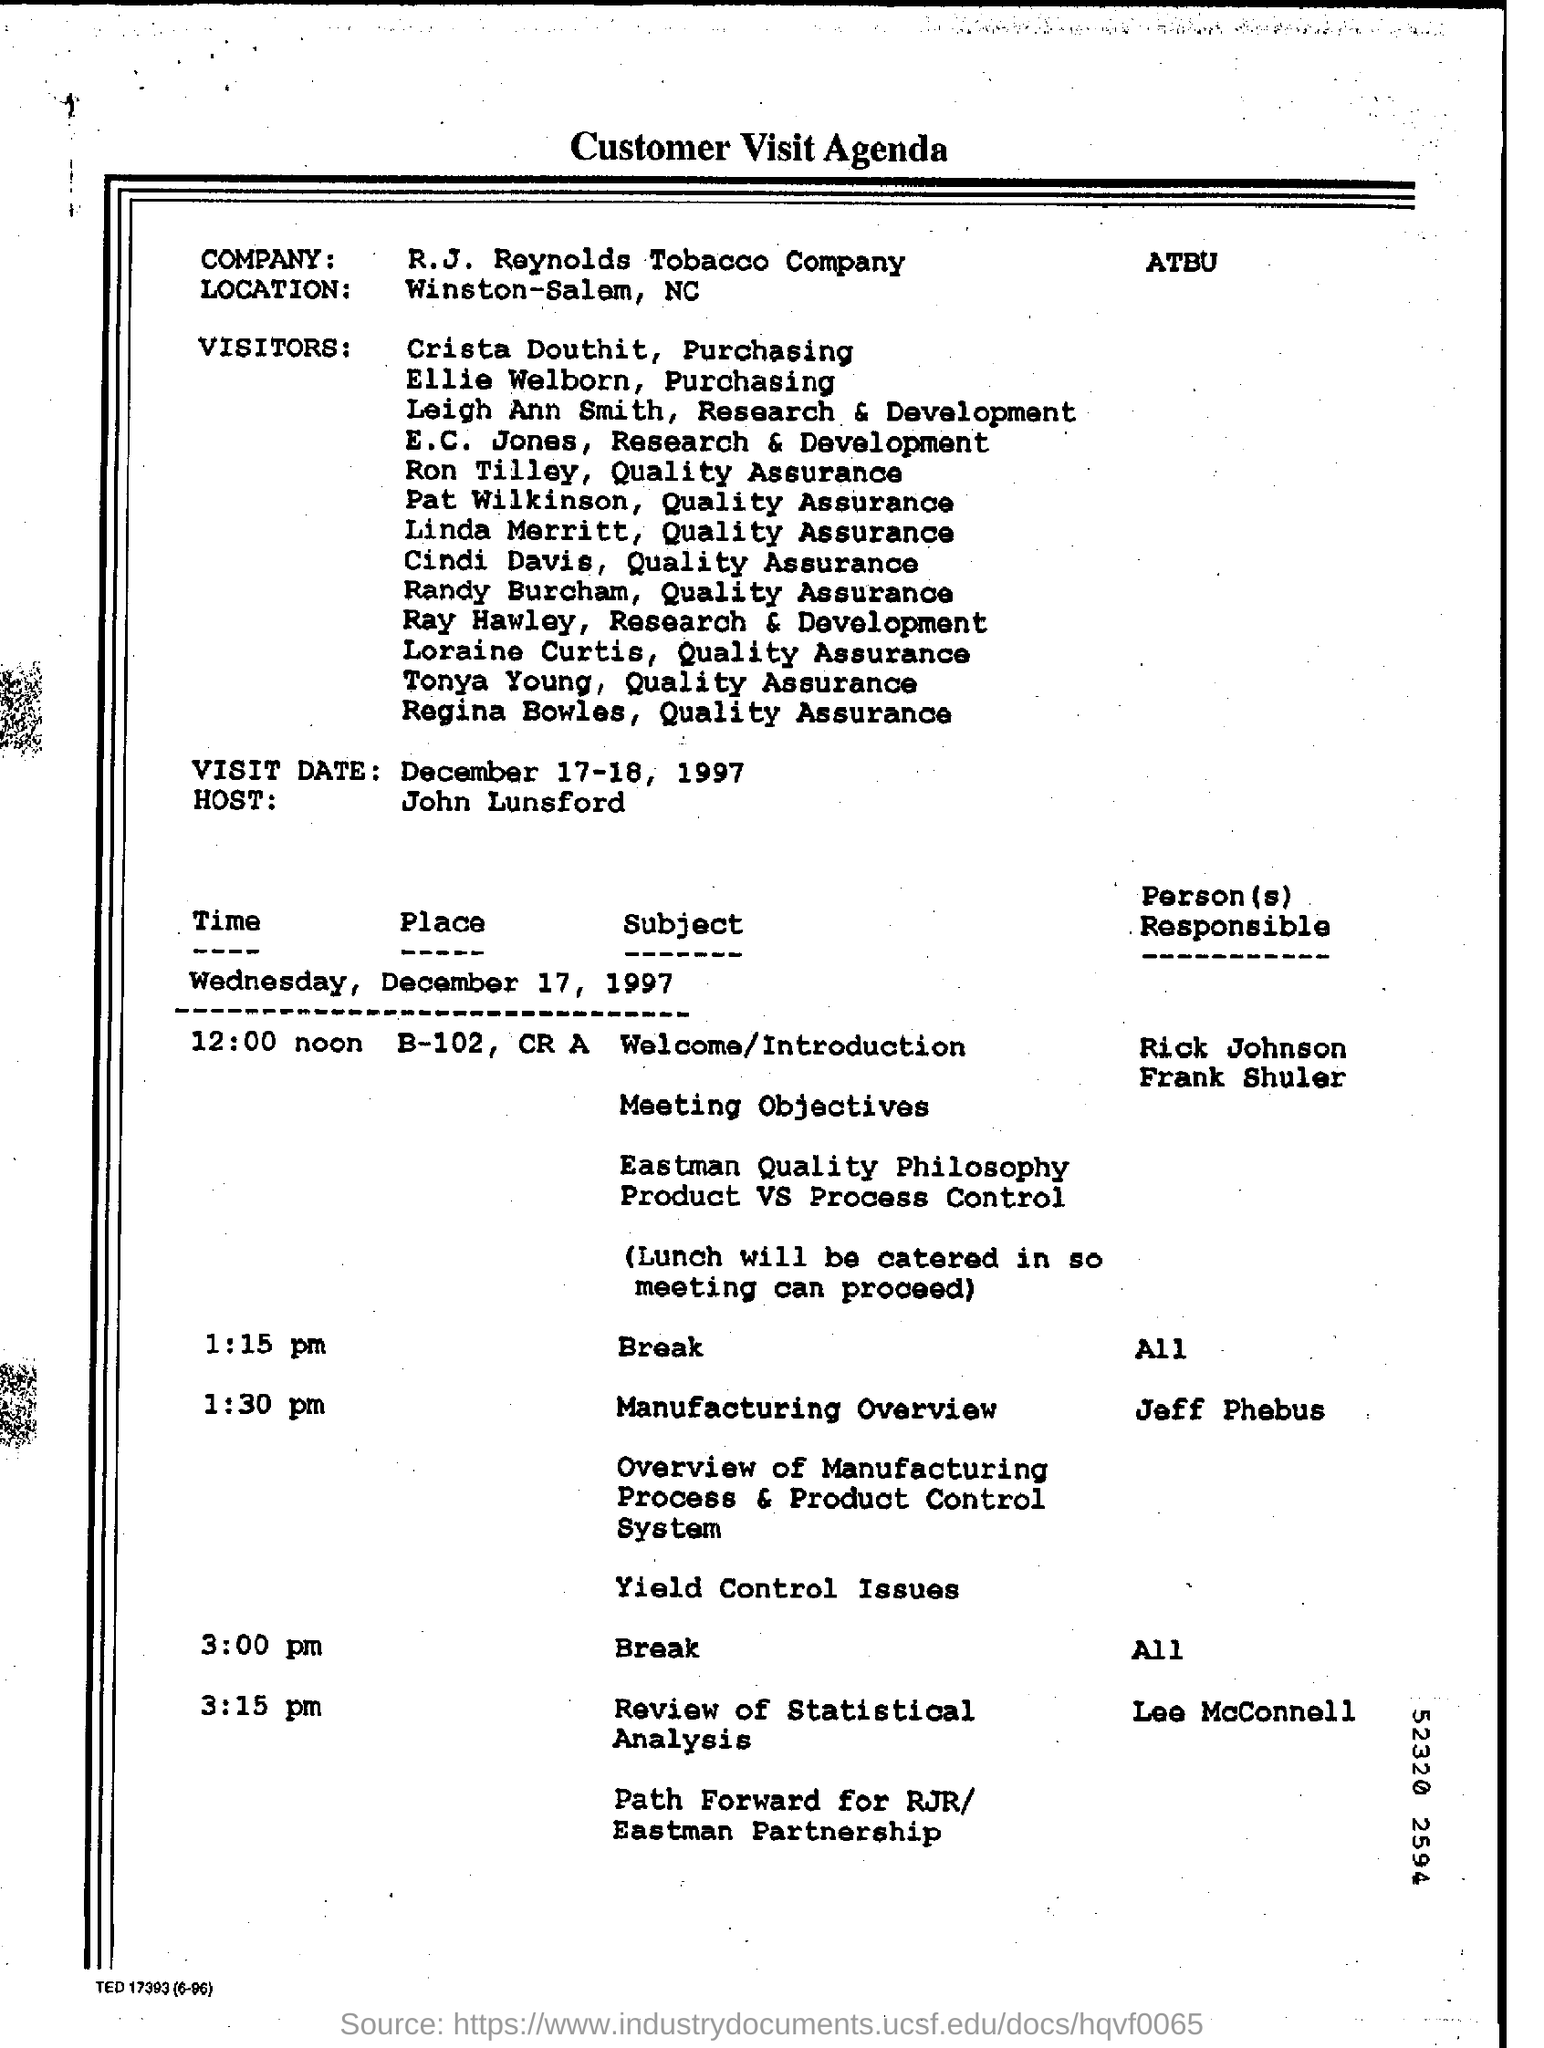Where is the company located?
Your answer should be compact. Winston-Salem, NC. Who's hosting the customer visit?
Keep it short and to the point. John Lunsford. Who is presenting the manufacturing overview?
Offer a terse response. Jeff Phebus. When will the first break start ?
Offer a very short reply. 1:15 pm. When is the second break scheduled?
Ensure brevity in your answer.  3:00 pm. 